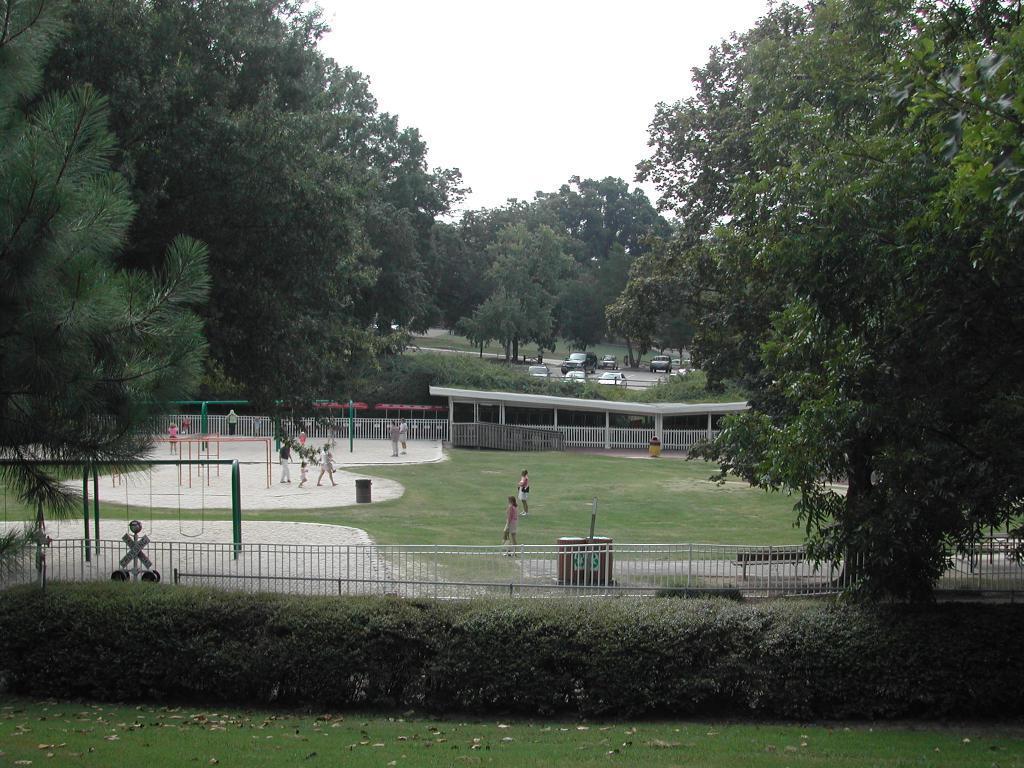How would you summarize this image in a sentence or two? In this image, we can see so many trees, railings, grass and plants. In the middle of the image, we can see few people, some roads and vehicles. Top of the image, there is a sky. 